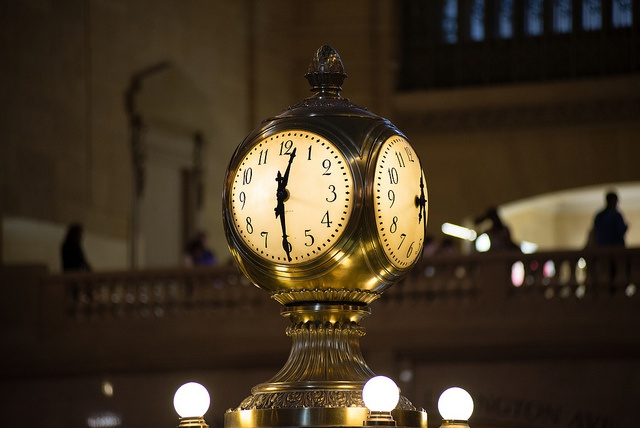Describe the objects in this image and their specific colors. I can see clock in black, khaki, beige, and tan tones, clock in black, khaki, tan, and gold tones, people in black and gray tones, people in black tones, and people in black tones in this image. 